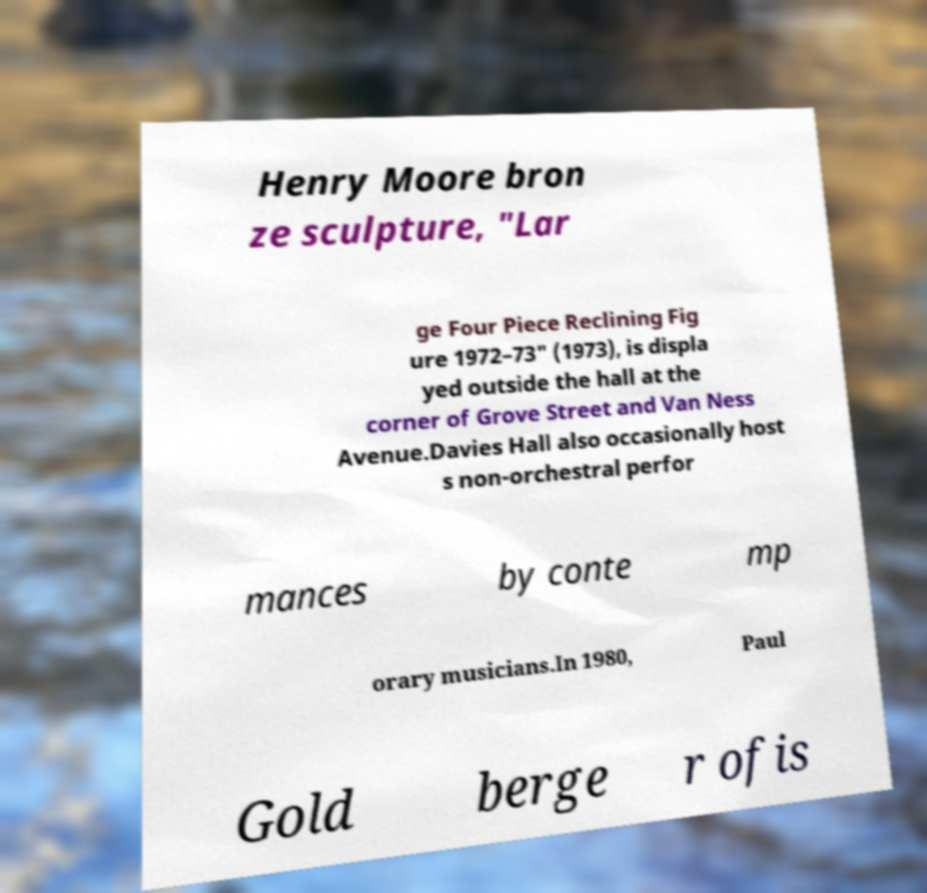What messages or text are displayed in this image? I need them in a readable, typed format. Henry Moore bron ze sculpture, "Lar ge Four Piece Reclining Fig ure 1972–73" (1973), is displa yed outside the hall at the corner of Grove Street and Van Ness Avenue.Davies Hall also occasionally host s non-orchestral perfor mances by conte mp orary musicians.In 1980, Paul Gold berge r ofis 